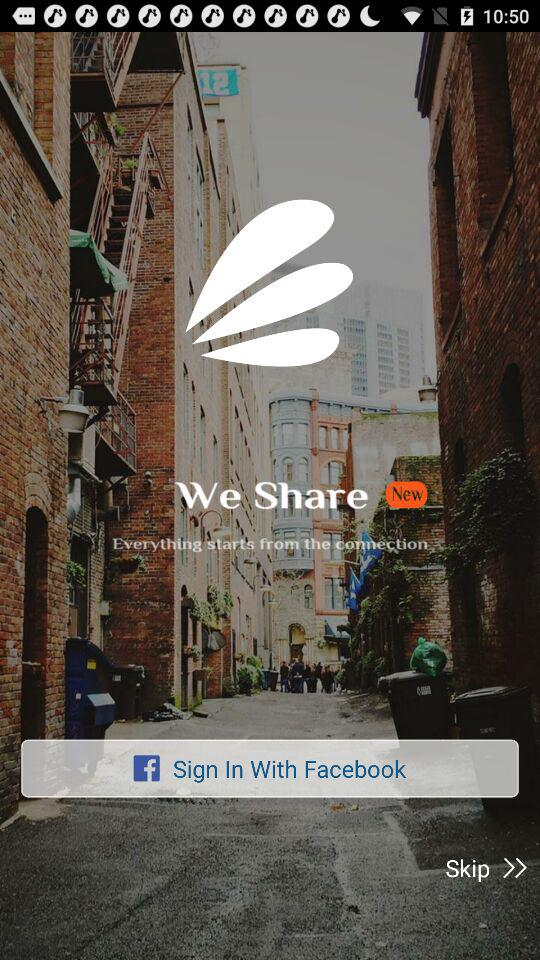What application can be used to sign in to the profile? The application used to sign in to the profile is "Sign In With Facebook". 